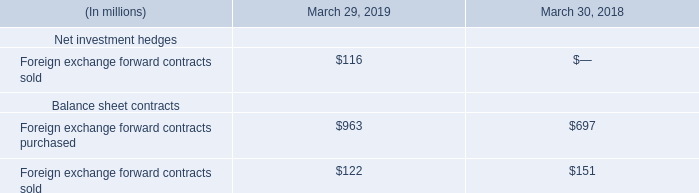The fair value of our foreign exchange forward contracts is presented on a gross basis in our Condensed Consolidated Balance Sheets. To mitigate losses in the event of nonperformance by counterparties, we have entered into master netting arrangements with our counterparties that allow us to settle payments on a net basis. The effect of netting on our derivative assets and liabilities was not material as of March 29, 2019 and March 30, 2018.
The notional amount of our outstanding foreign exchange forward contracts in U.S. dollar equivalent was as follows:
What does the table show? Notional amount of our outstanding foreign exchange forward contracts in u.s. dollar equivalent was as follows. How is the fair value of foreign exchange forward contracts presented? On a gross basis in our condensed consolidated balance sheets. What is the Foreign exchange forward contracts sold as of March 29, 2019?
Answer scale should be: million. $116. What is the total Foreign exchange forward contracts purchased for March 29, 2019 and March 30, 2018?
Answer scale should be: million. 963+697
Answer: 1660. What is the total Foreign exchange forward contracts sold for March 29, 2019 and March 30, 2018?
Answer scale should be: million. 122+151
Answer: 273. What is the change between Foreign exchange forward contracts purchased for March 29, 2019 and March 30, 2018?
Answer scale should be: million. 963-697
Answer: 266. 